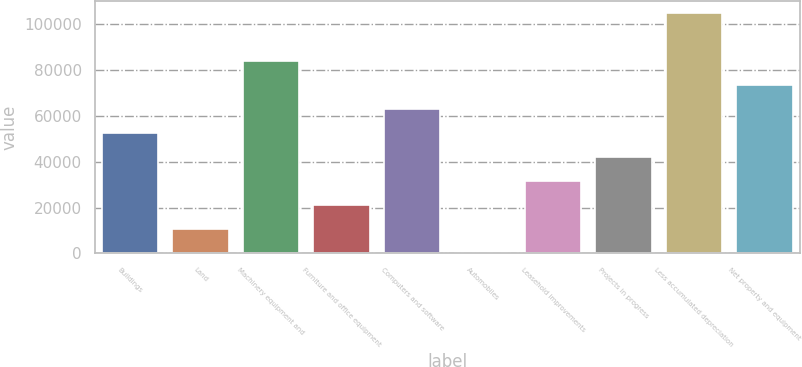Convert chart to OTSL. <chart><loc_0><loc_0><loc_500><loc_500><bar_chart><fcel>Buildings<fcel>Land<fcel>Machinery equipment and<fcel>Furniture and office equipment<fcel>Computers and software<fcel>Automobiles<fcel>Leasehold improvements<fcel>Projects in progress<fcel>Less accumulated depreciation<fcel>Net property and equipment<nl><fcel>52576<fcel>10555.2<fcel>84091.6<fcel>21060.4<fcel>63081.2<fcel>50<fcel>31565.6<fcel>42070.8<fcel>105102<fcel>73586.4<nl></chart> 